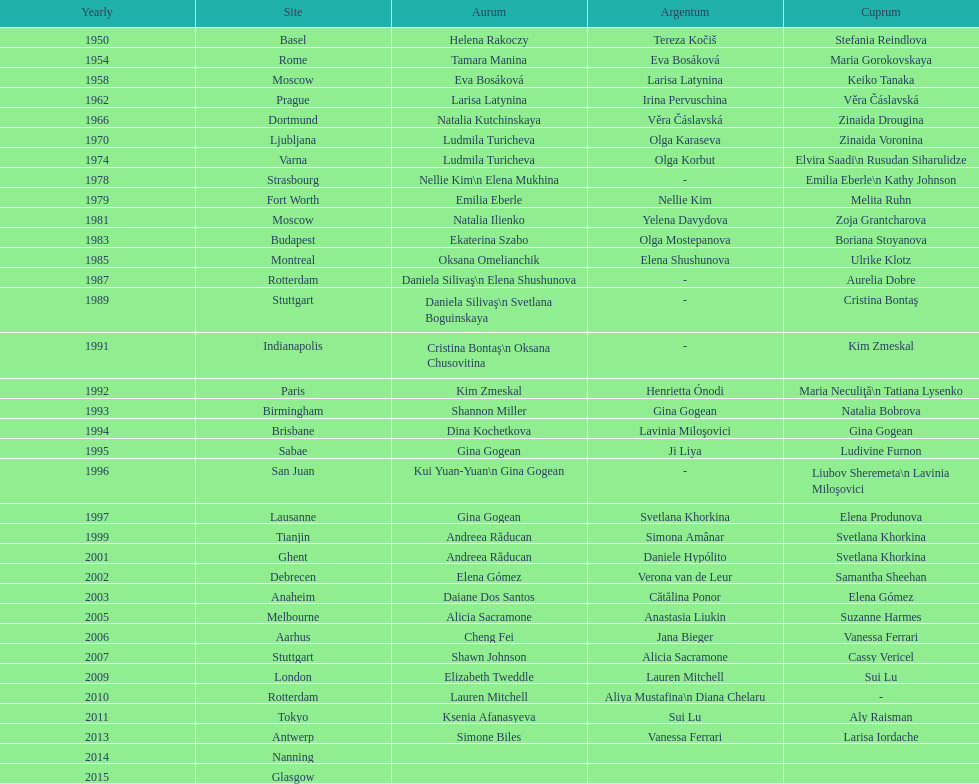What is the number of times a brazilian has won a medal? 2. 